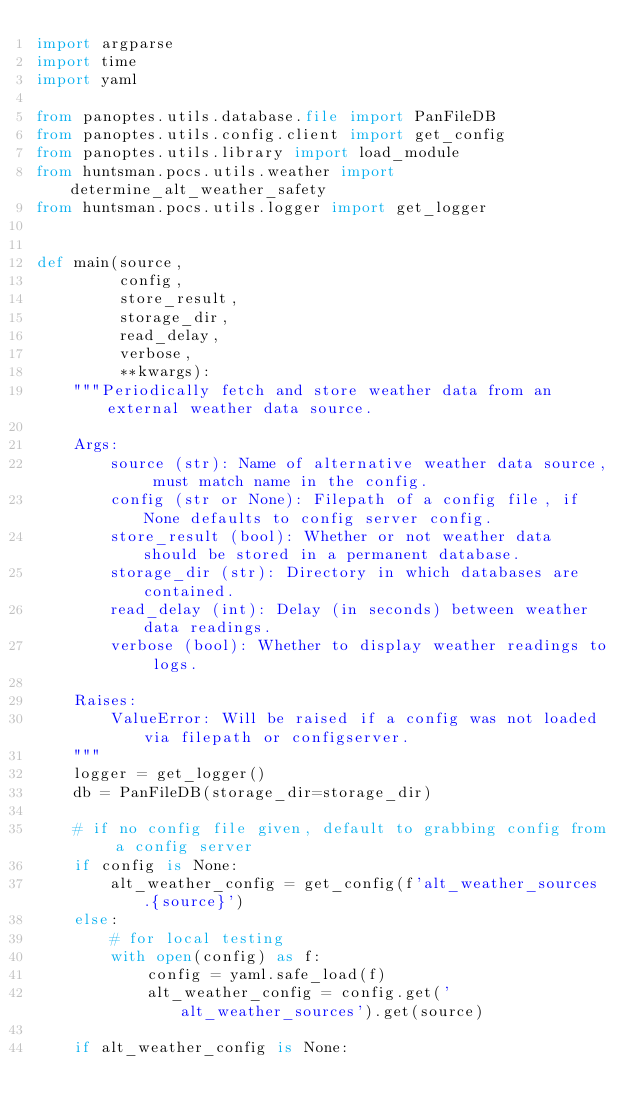Convert code to text. <code><loc_0><loc_0><loc_500><loc_500><_Python_>import argparse
import time
import yaml

from panoptes.utils.database.file import PanFileDB
from panoptes.utils.config.client import get_config
from panoptes.utils.library import load_module
from huntsman.pocs.utils.weather import determine_alt_weather_safety
from huntsman.pocs.utils.logger import get_logger


def main(source,
         config,
         store_result,
         storage_dir,
         read_delay,
         verbose,
         **kwargs):
    """Periodically fetch and store weather data from an external weather data source.

    Args:
        source (str): Name of alternative weather data source, must match name in the config.
        config (str or None): Filepath of a config file, if None defaults to config server config.
        store_result (bool): Whether or not weather data should be stored in a permanent database.
        storage_dir (str): Directory in which databases are contained.
        read_delay (int): Delay (in seconds) between weather data readings.
        verbose (bool): Whether to display weather readings to logs.

    Raises:
        ValueError: Will be raised if a config was not loaded via filepath or configserver.
    """
    logger = get_logger()
    db = PanFileDB(storage_dir=storage_dir)

    # if no config file given, default to grabbing config from a config server
    if config is None:
        alt_weather_config = get_config(f'alt_weather_sources.{source}')
    else:
        # for local testing
        with open(config) as f:
            config = yaml.safe_load(f)
            alt_weather_config = config.get('alt_weather_sources').get(source)

    if alt_weather_config is None:</code> 